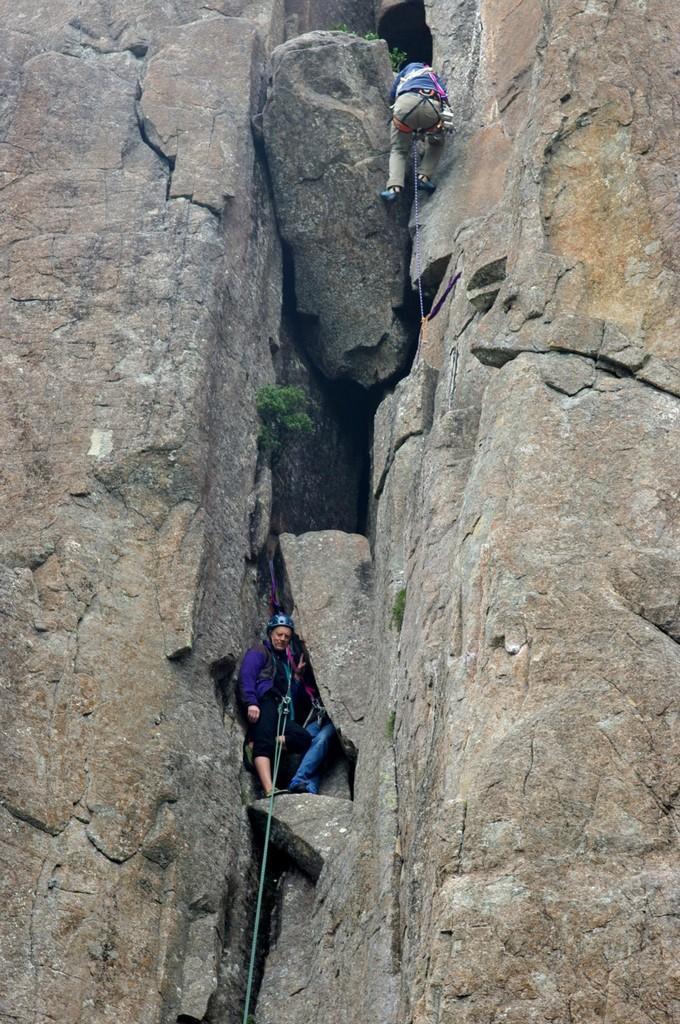Could you give a brief overview of what you see in this image? In this image we can see there are two people climbing the rocks. 